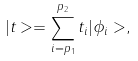<formula> <loc_0><loc_0><loc_500><loc_500>| t > = \sum _ { i = p _ { 1 } } ^ { p _ { 2 } } t _ { i } | \phi _ { i } > ,</formula> 